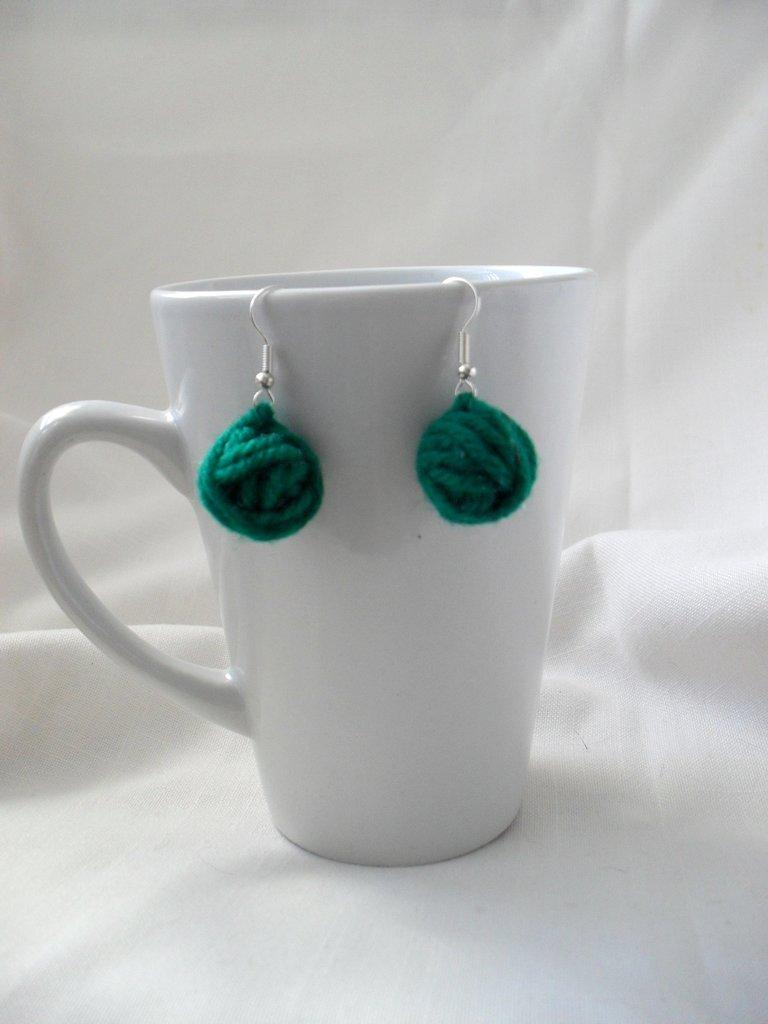What object is present in the image that can hold liquid? There is a cup in the image that can hold liquid. What is the cup placed on? The cup is on a white cloth. What type of accessory is on the cup? There is a pair of earrings on the cup. What type of oil is being used to clean the silk in the image? There is no oil or silk present in the image; it only features a cup, a white cloth, and a pair of earrings. 